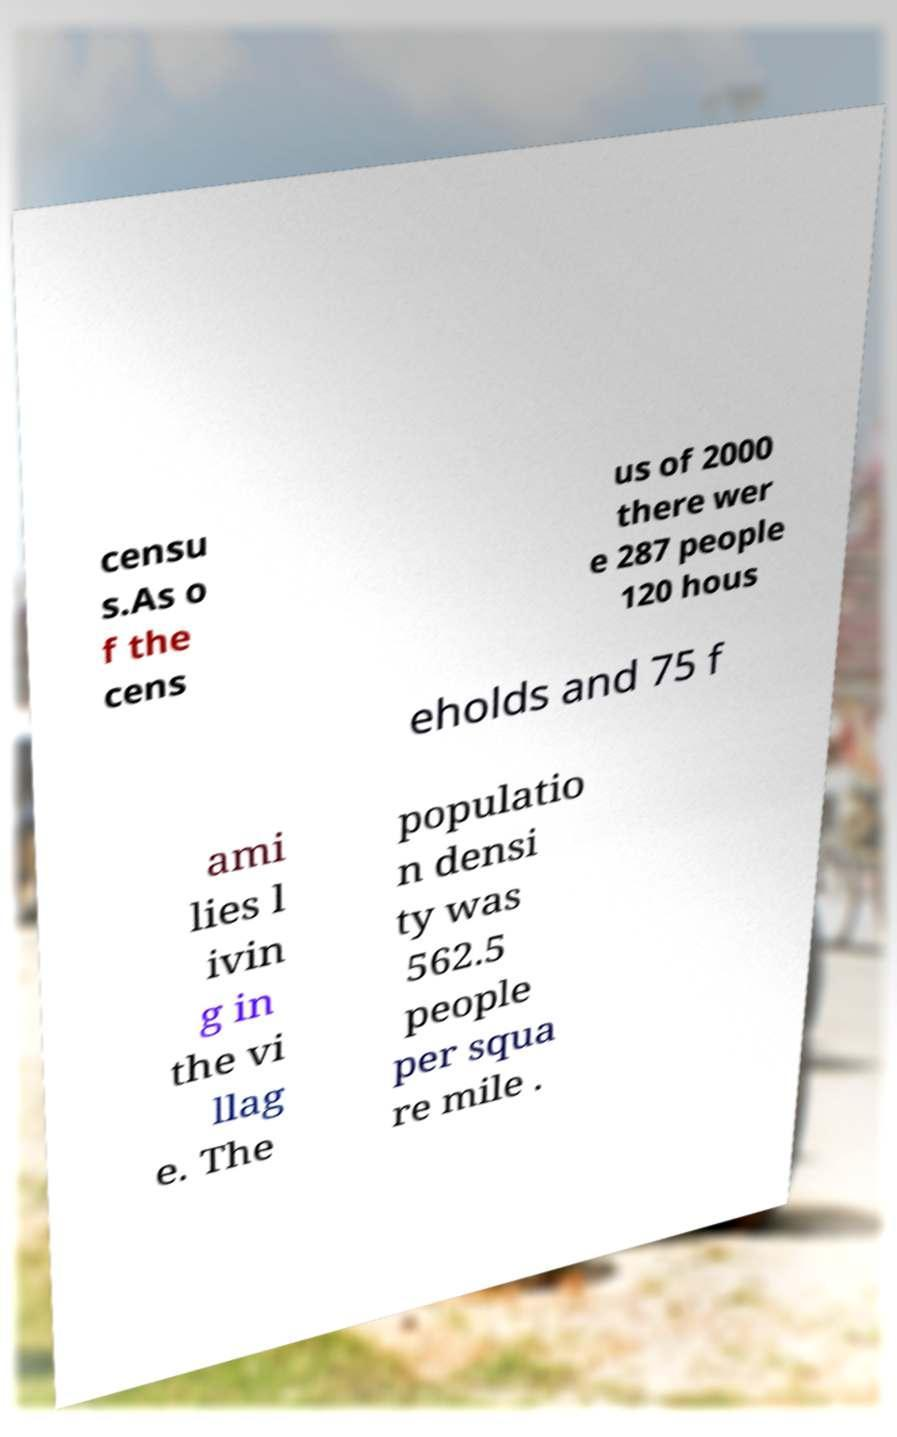I need the written content from this picture converted into text. Can you do that? censu s.As o f the cens us of 2000 there wer e 287 people 120 hous eholds and 75 f ami lies l ivin g in the vi llag e. The populatio n densi ty was 562.5 people per squa re mile . 